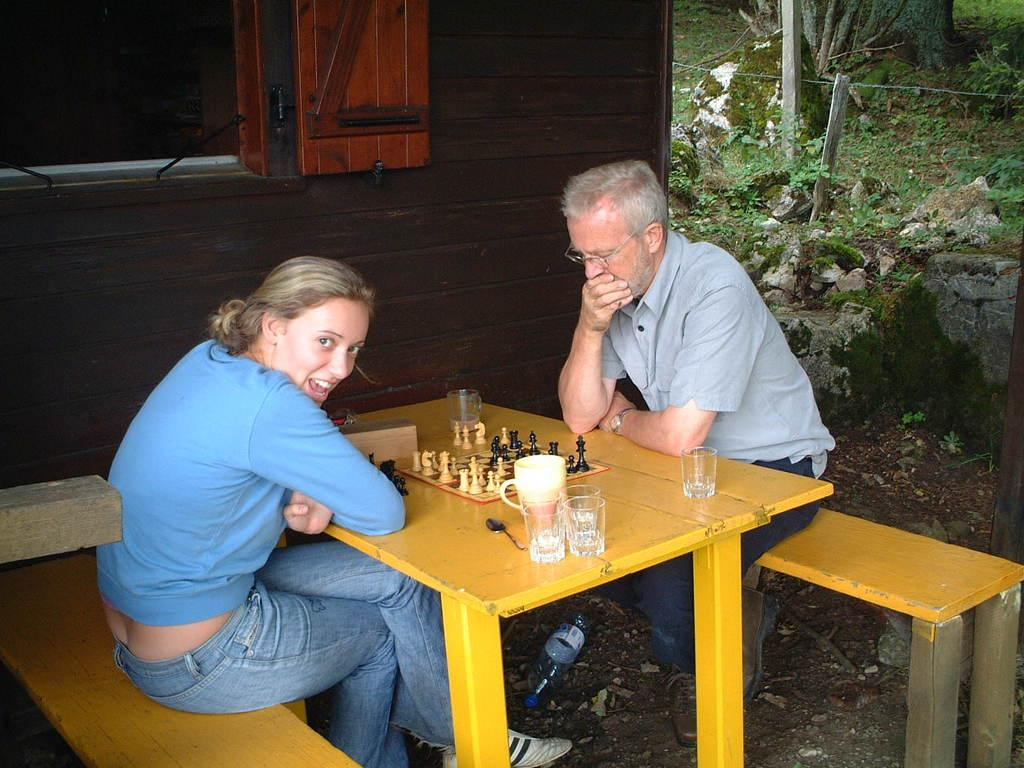What activity are the two people engaged in? The two people are playing chess. What can be seen on the table in the image? There is a water bottle, a glass, and a spoon on the table. Can you describe the objects on the table in more detail? The water bottle is likely for hydration, the glass could be for drinking or holding something, and the spoon might be used for stirring or eating. What type of crow is sitting on the desk in the image? There is no crow or desk present in the image. What type of lunch is being served on the table in the image? There is no lunch present in the image; the focus is on the chess game and the objects on the table. 